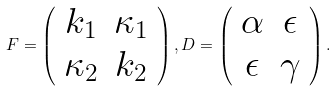<formula> <loc_0><loc_0><loc_500><loc_500>F = \left ( \begin{array} { c c } k _ { 1 } & \kappa _ { 1 } \\ \kappa _ { 2 } & k _ { 2 } \end{array} \right ) , D = \left ( \begin{array} { c c } \alpha & \epsilon \\ \epsilon & \gamma \end{array} \right ) .</formula> 